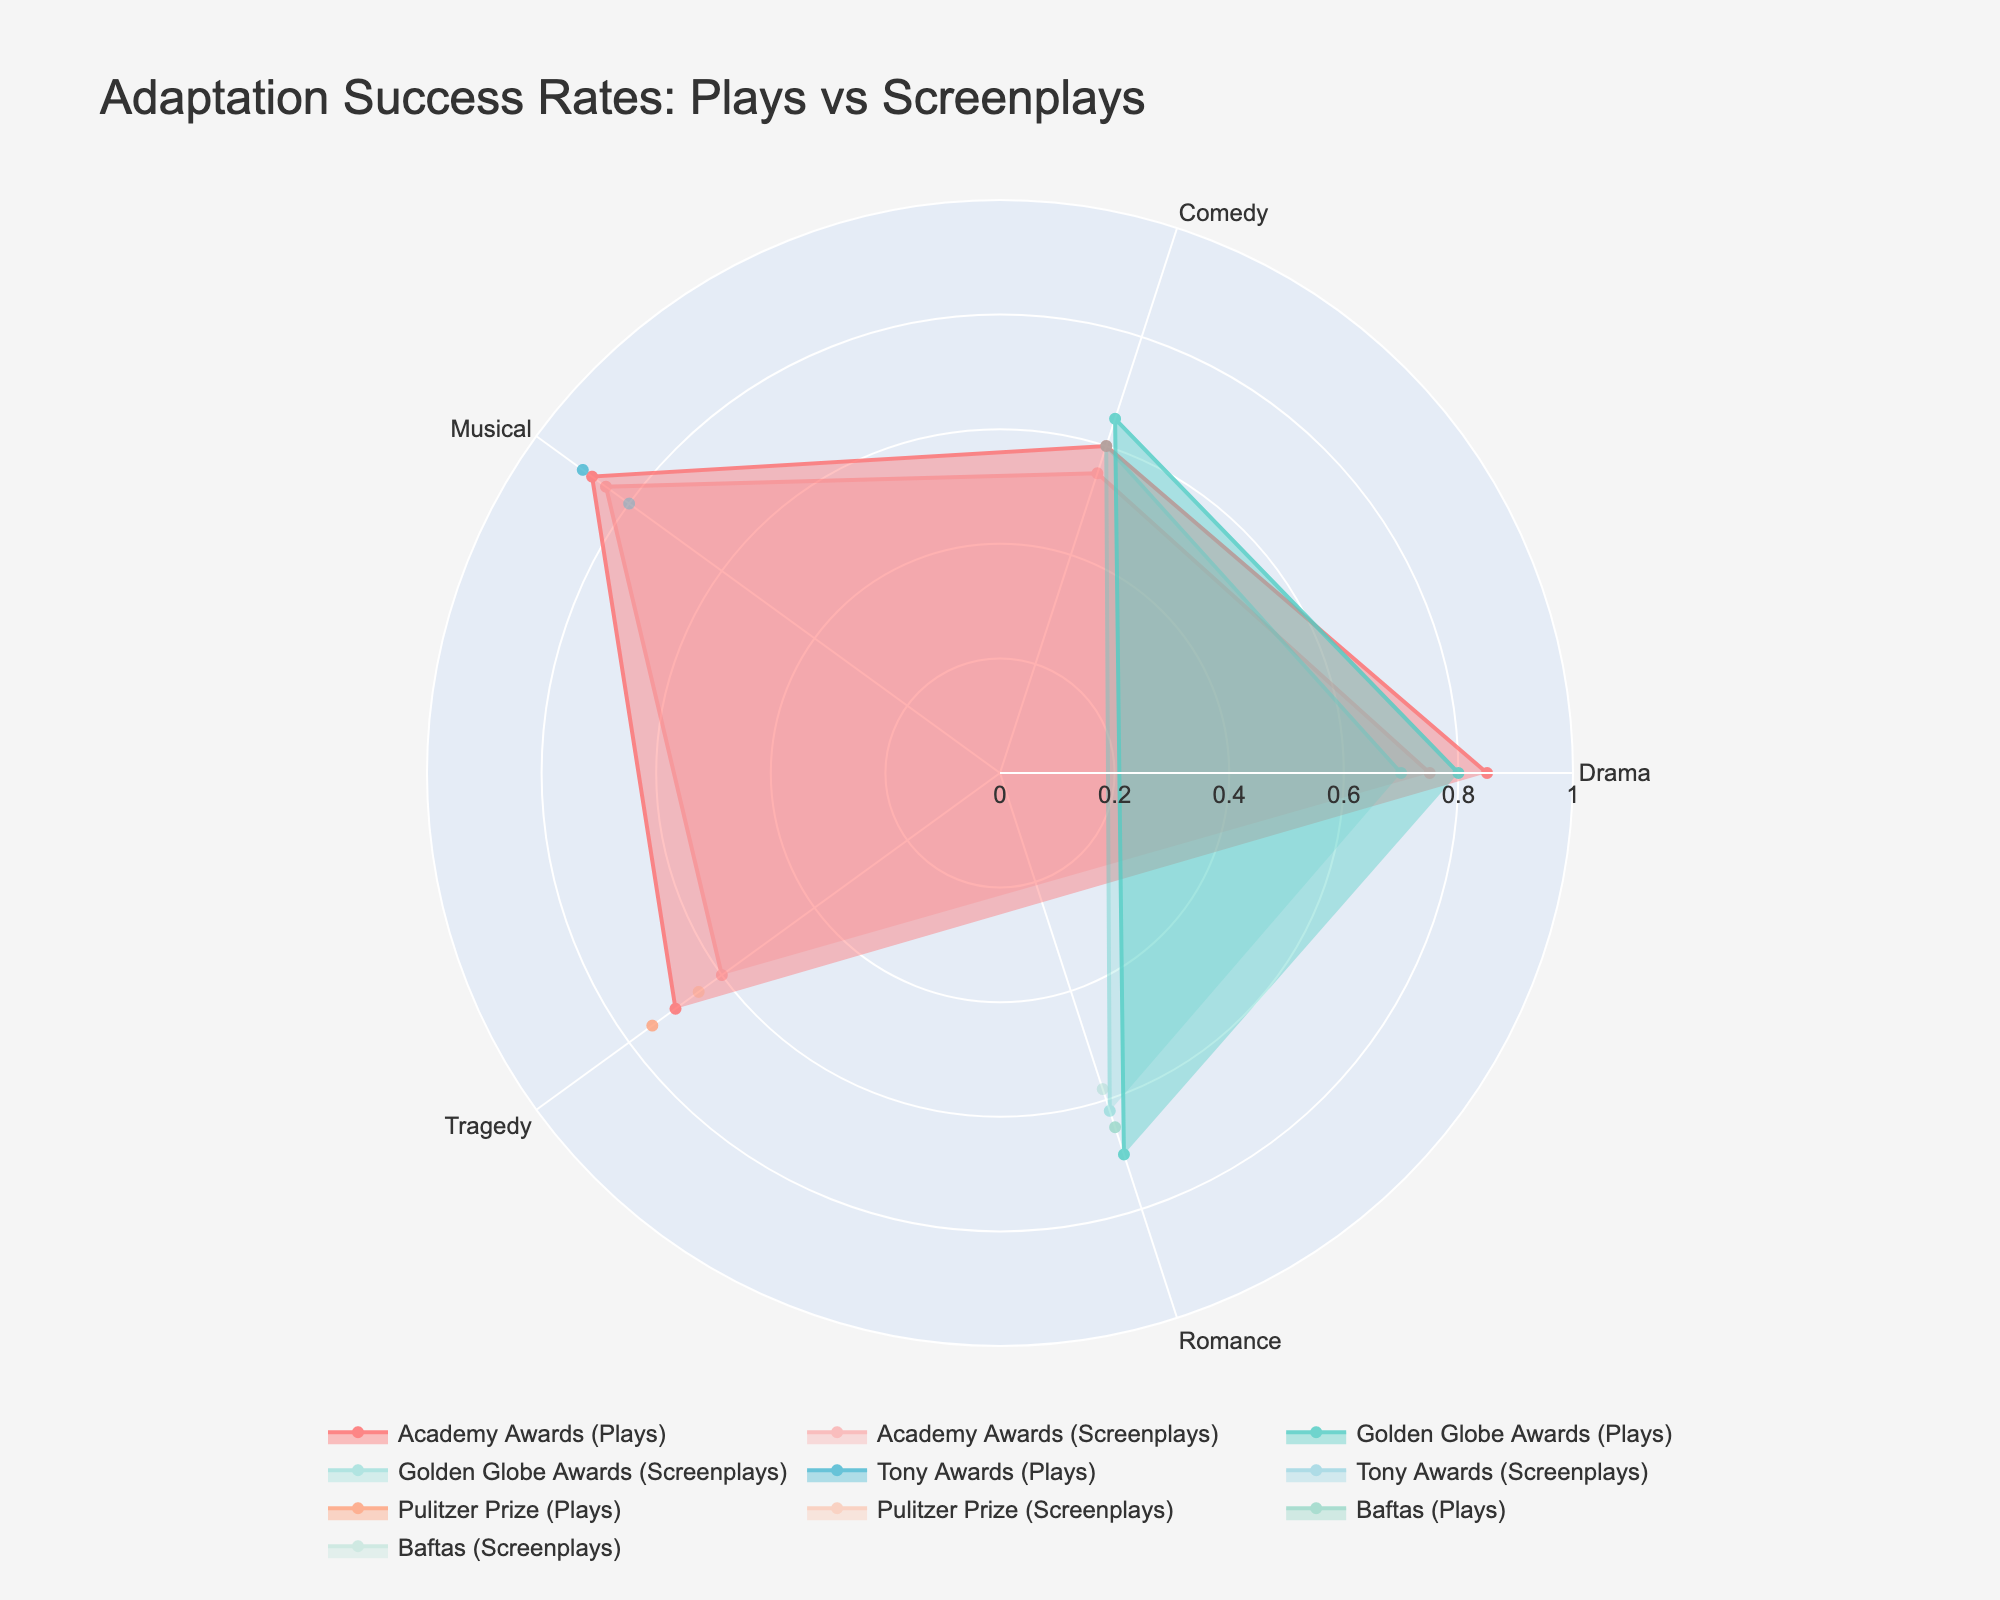What is the title of the figure? The title is usually located at the top of the figure and provides a brief description of what the figure is about. In this case, it reads 'Adaptation Success Rates: Plays vs Screenplays.'
Answer: Adaptation Success Rates: Plays vs Screenplays Which genre and award have the highest adaptation success rate for plays? To find this, you look at the outermost point on the radar chart for each award. For plays, the highest point is in the "Musical" genre with "Tony Awards" at 90%.
Answer: Musical, Tony Awards How does the success rate of "Drama" plays compare to "Drama" screenplays for Academy Awards? Locate the points for "Drama" under the Academy Awards on both the "Plays" and "Screenplays" radar charts. Compare the radial distances from the center. The play's success rate is at 85%, while the screenplay's success rate is at 75%, indicating that the success rate for plays is higher.
Answer: Plays have a higher success rate What is the average adaptation success rate for screenplays in the "Drama" genre across all awards? First, identify the success rates for Drama screenplays across different awards: Academy Awards (75%), Golden Globe Awards (70%). Then, calculate the average: (75% + 70%) / 2 = 72.5%.
Answer: 72.5% Which award shows a greater difference in adaptation success rates between plays and screenplays in the "Comedy" genre? The difference is calculated by subtracting the screenplay success rate from the play success rate for each award. For Academy Awards, it's 60% - 55% = 5%. For Golden Globe Awards, it's 65% - 60% = 5%. Both show the same difference.
Answer: Both have the same difference What genre has the smallest drop in adaptation success rate when moving from plays to screenplays for Tony Awards? Tony Awards data is available only for the "Musical" genre. The drop is calculated by subtracting the screenplay success rate from the play success rate: 90% - 80% = 10%. Since it's the only data point, it's the one with the smallest drop.
Answer: Musical Which award has the highest overall adaptation success rate for screenplays? To determine this, identify the highest point for screenplays across all awards and genres. For screenplays, the highest point is in the "Musical" genre for "Academy Awards" at 85%.
Answer: Academy Awards How does the success rate for "Tragedy" plays that won the Pulitzer Prize compare to those that won the Academy Awards? Locate the "Tragedy" points for both the Pulitzer Prize and Academy Awards on the plays radar chart and compare them. Pulitzer Prize has a success rate of 75%, while Academy Awards have a success rate of 70%.
Answer: Pulitzer Prize has a higher success rate Which genre and award combination has an overall lower success rate, and what is the rate? For this, check the genres and awards for the lowest data points on the radar chart. The lowest adaptation success rate combination is "Comedy" with "Academy Awards" for screenplays, which has a 55% success rate.
Answer: Comedy, Academy Awards, 55% 